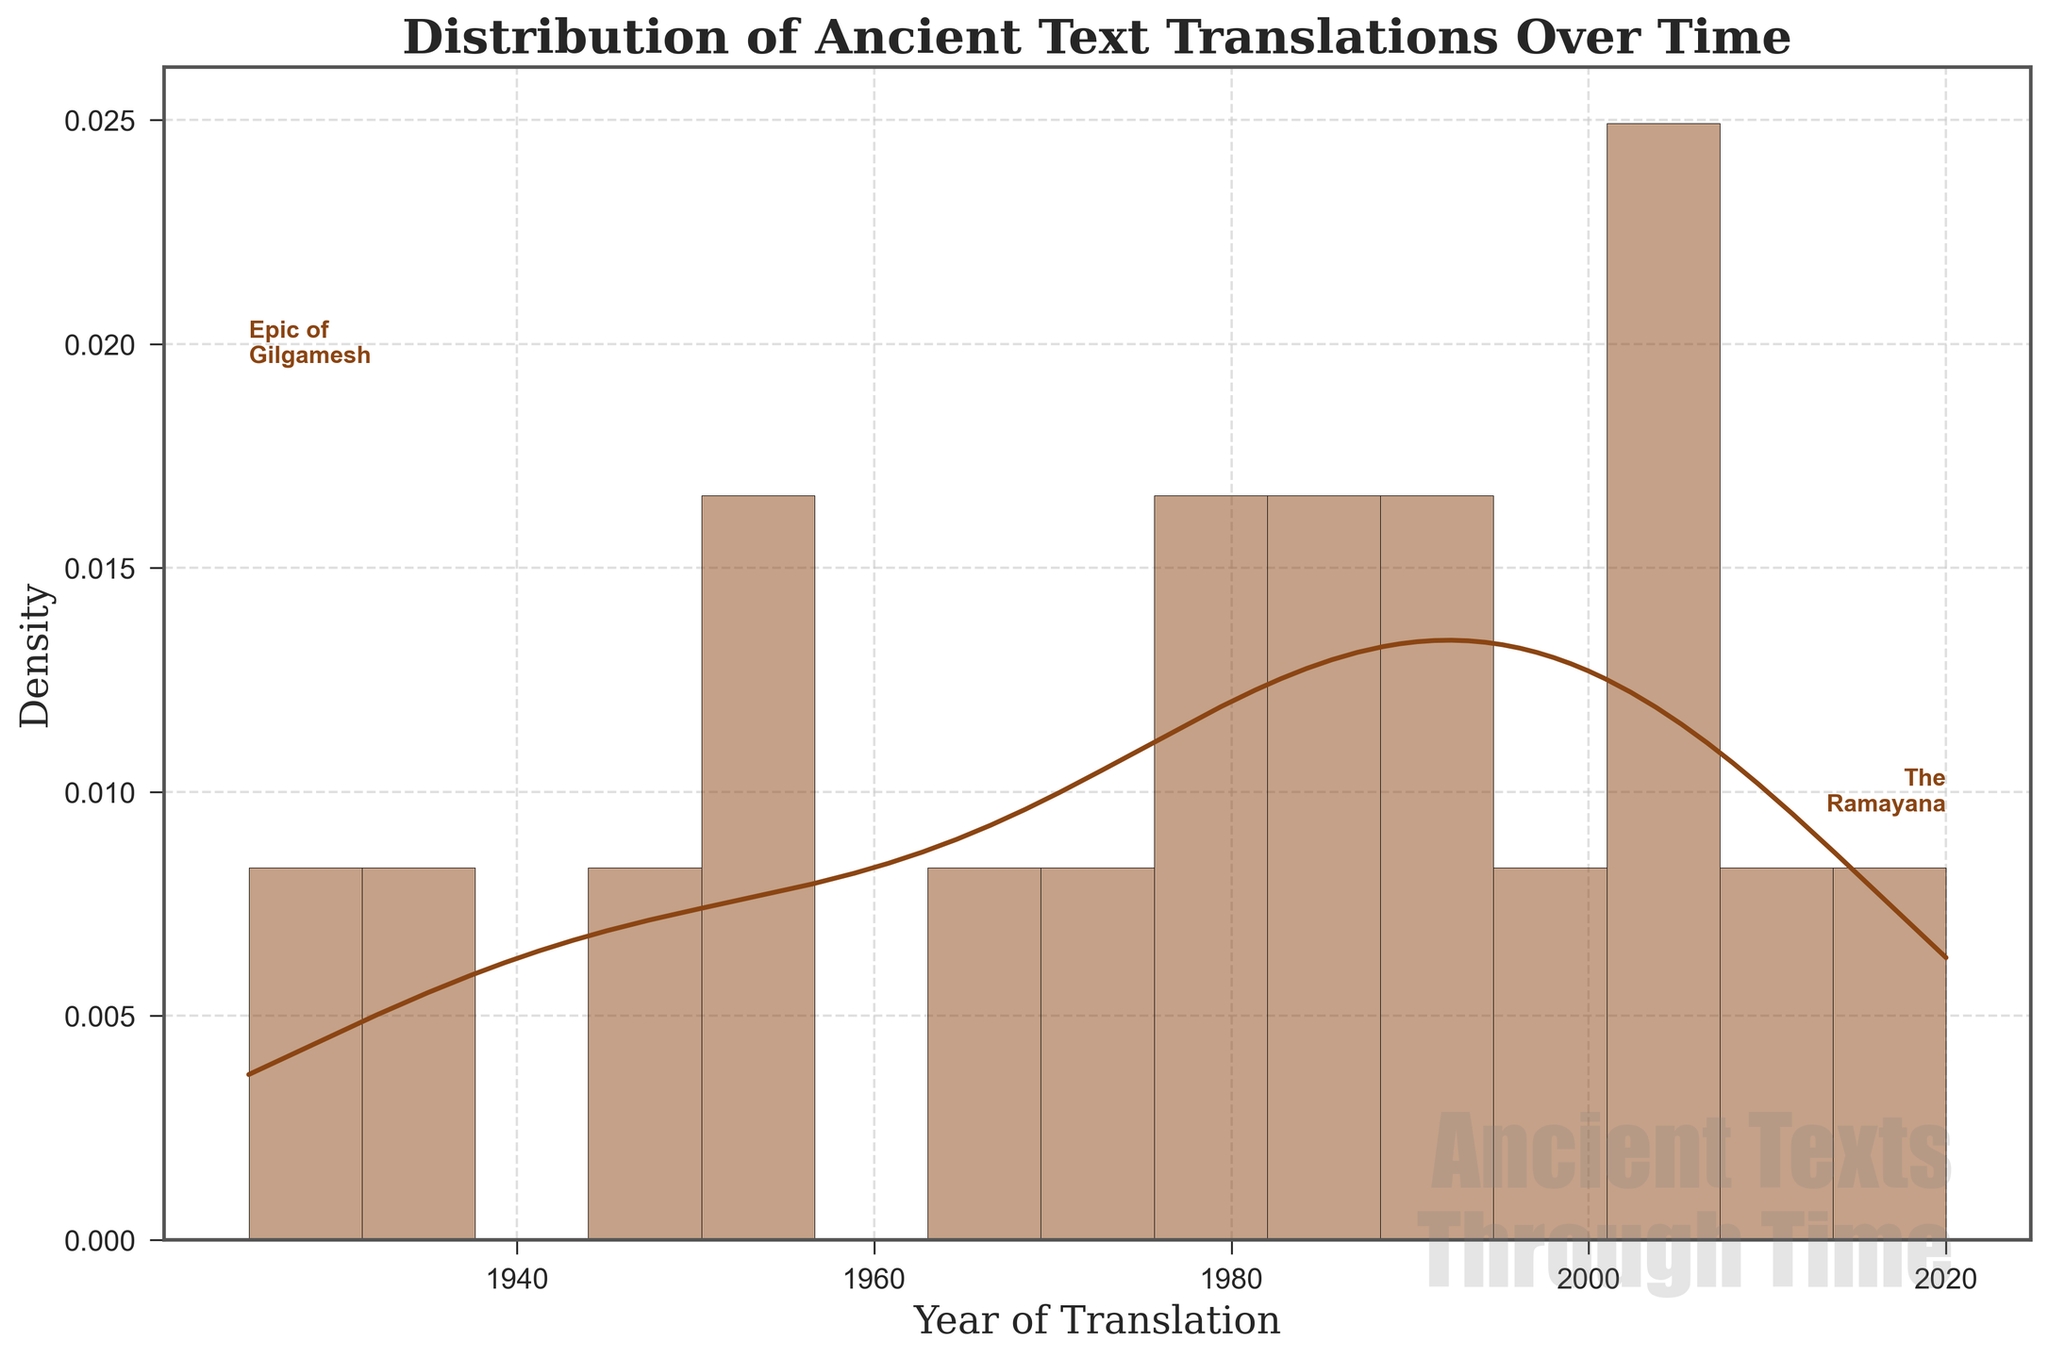what is the title of the plot? The title is located at the top of the figure and it's meant to describe the general content of the plot.
Answer: Distribution of Ancient Text Translations Over Time What is the total number of unique translation years in the plot? By counting the distinct years on the x-axis, we can determine the total number of unique translation years represented in the histogram.
Answer: 18 Which two ancient texts have text annotations in the plot? From the annotations provided in the plot, it can be observed which specific ancient texts have text labels associated with them.
Answer: The Epic of Gilgamesh and The Ramayana In what year did the highest density of translations occur? By examining the peaks of the density curve represented in the plot, we can identify the year with the highest translation density.
Answer: 1950-1960 Between which years did the translation density increase the most? By analyzing the slope and trend of the density line, we can determine the range of years where there was a significant increase in translation density.
Answer: 1940-1960 Which region has the highest number of translated texts based on the plot data annotations? The annotations or contextual hints in the plot help indicate the most frequent region associated with the translations during the century.
Answer: Ancient Greece What is the approximate density range indicated in the plot? Observing the y-axis of the plot gives insight into the density values that are represented throughout the figure.
Answer: 0.00 to 0.025 